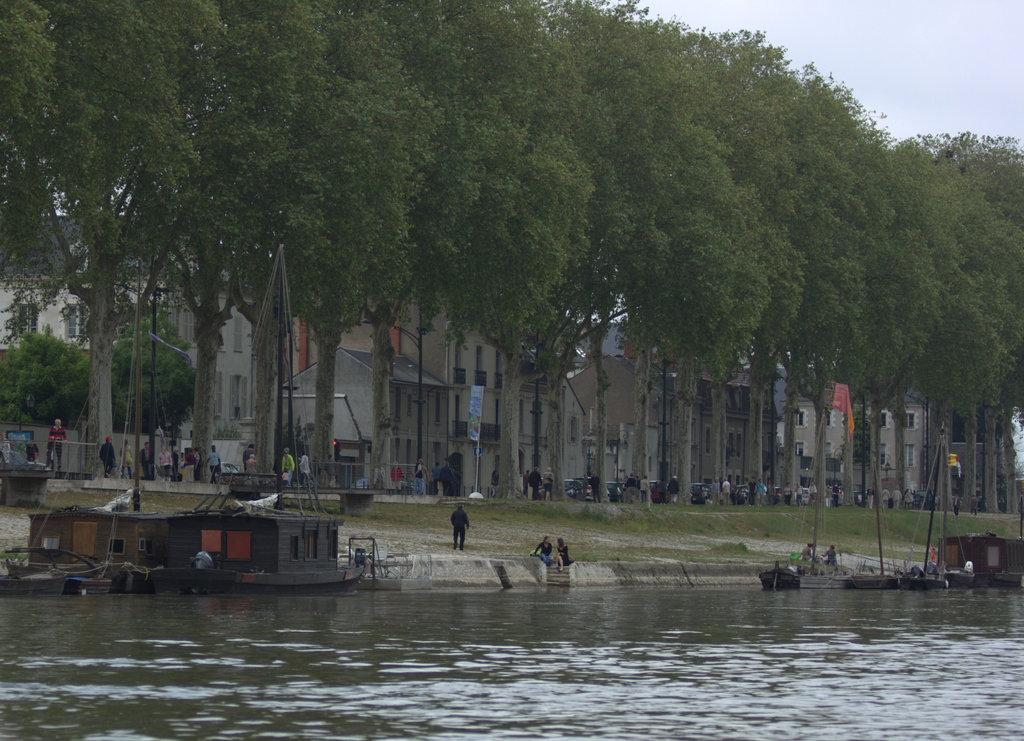What type of natural elements can be seen in the image? There are trees in the image. What type of man-made structures are present in the image? There are buildings in the image. What are the vertical structures in the image used for? There are poles in the image, which are likely used for support or signage. What type of transportation is visible in the image? There are boats in the image. What is the primary body of water in the image? There is water visible in the image. Are there any human figures in the image? Yes, there are people in the image. What is the color of the sky in the image? The sky is blue and white in color. Can you see a receipt for the purchase of a faucet in the image? There is no receipt or faucet present in the image. What type of air is visible in the image? The image does not show any specific type of air; it simply shows the sky, which is a mixture of gases. 